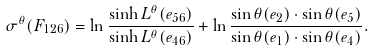Convert formula to latex. <formula><loc_0><loc_0><loc_500><loc_500>\sigma ^ { \theta } ( F _ { 1 2 6 } ) = \ln \frac { \sinh L ^ { \theta } ( e _ { 5 6 } ) } { \sinh L ^ { \theta } ( e _ { 4 6 } ) } + \ln \frac { \sin \theta ( e _ { 2 } ) \cdot \sin \theta ( e _ { 5 } ) } { \sin \theta ( e _ { 1 } ) \cdot \sin \theta ( e _ { 4 } ) } .</formula> 